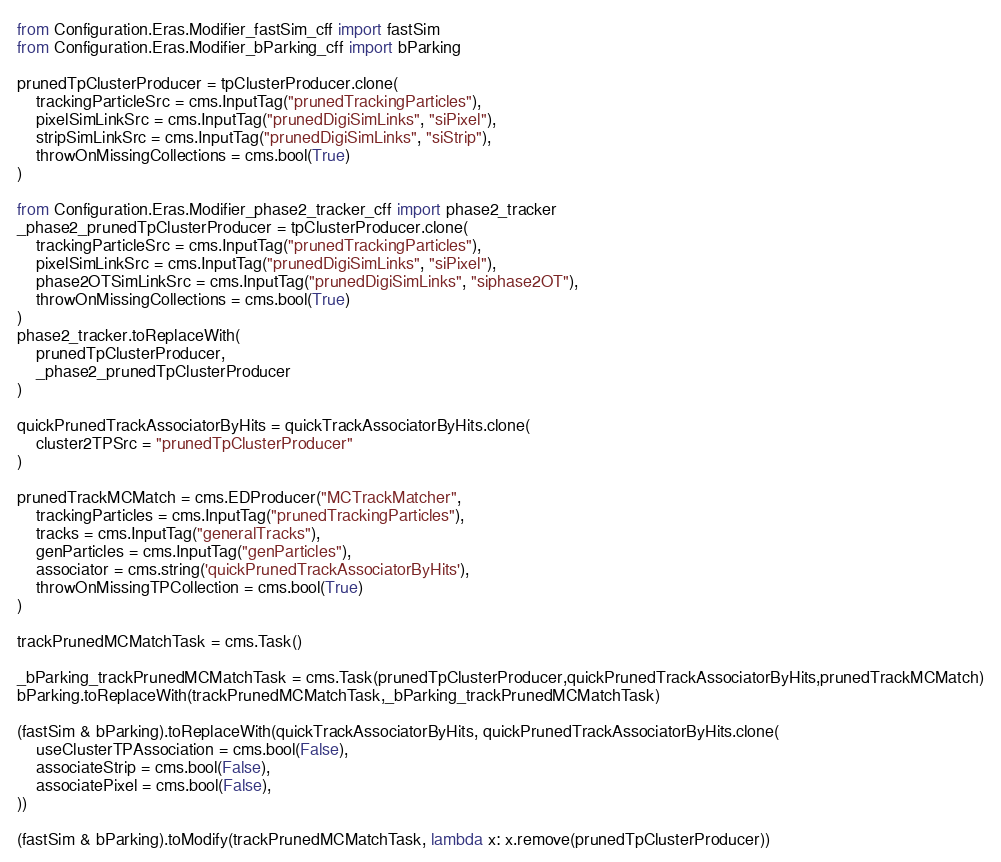Convert code to text. <code><loc_0><loc_0><loc_500><loc_500><_Python_>
from Configuration.Eras.Modifier_fastSim_cff import fastSim
from Configuration.Eras.Modifier_bParking_cff import bParking

prunedTpClusterProducer = tpClusterProducer.clone(
    trackingParticleSrc = cms.InputTag("prunedTrackingParticles"),
    pixelSimLinkSrc = cms.InputTag("prunedDigiSimLinks", "siPixel"),
    stripSimLinkSrc = cms.InputTag("prunedDigiSimLinks", "siStrip"),
    throwOnMissingCollections = cms.bool(True)
)

from Configuration.Eras.Modifier_phase2_tracker_cff import phase2_tracker
_phase2_prunedTpClusterProducer = tpClusterProducer.clone(
    trackingParticleSrc = cms.InputTag("prunedTrackingParticles"),
    pixelSimLinkSrc = cms.InputTag("prunedDigiSimLinks", "siPixel"),
    phase2OTSimLinkSrc = cms.InputTag("prunedDigiSimLinks", "siphase2OT"),
    throwOnMissingCollections = cms.bool(True)
)
phase2_tracker.toReplaceWith( 
    prunedTpClusterProducer,
    _phase2_prunedTpClusterProducer
)

quickPrunedTrackAssociatorByHits = quickTrackAssociatorByHits.clone(
    cluster2TPSrc = "prunedTpClusterProducer"
)

prunedTrackMCMatch = cms.EDProducer("MCTrackMatcher",
    trackingParticles = cms.InputTag("prunedTrackingParticles"),
    tracks = cms.InputTag("generalTracks"),
    genParticles = cms.InputTag("genParticles"),
    associator = cms.string('quickPrunedTrackAssociatorByHits'),
    throwOnMissingTPCollection = cms.bool(True)
)

trackPrunedMCMatchTask = cms.Task()

_bParking_trackPrunedMCMatchTask = cms.Task(prunedTpClusterProducer,quickPrunedTrackAssociatorByHits,prunedTrackMCMatch)
bParking.toReplaceWith(trackPrunedMCMatchTask,_bParking_trackPrunedMCMatchTask)

(fastSim & bParking).toReplaceWith(quickTrackAssociatorByHits, quickPrunedTrackAssociatorByHits.clone(
    useClusterTPAssociation = cms.bool(False),
    associateStrip = cms.bool(False),
    associatePixel = cms.bool(False),
))

(fastSim & bParking).toModify(trackPrunedMCMatchTask, lambda x: x.remove(prunedTpClusterProducer))
</code> 